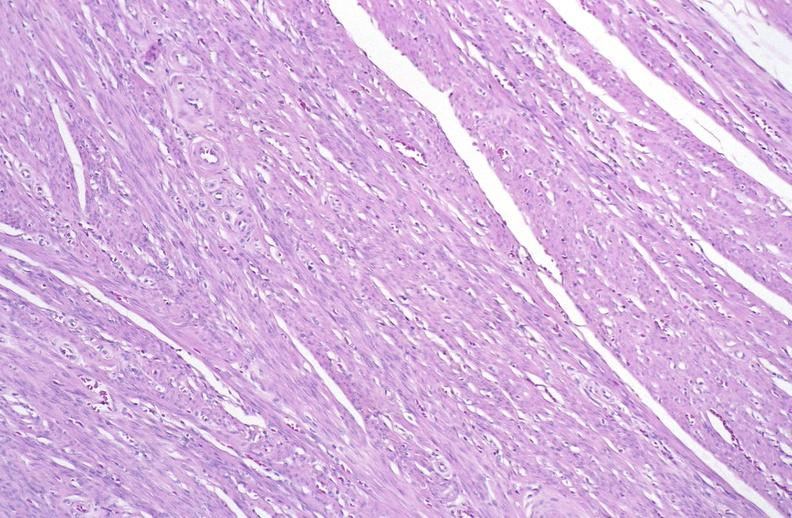does band constriction in skin above ankle of infant show normal uterus?
Answer the question using a single word or phrase. No 